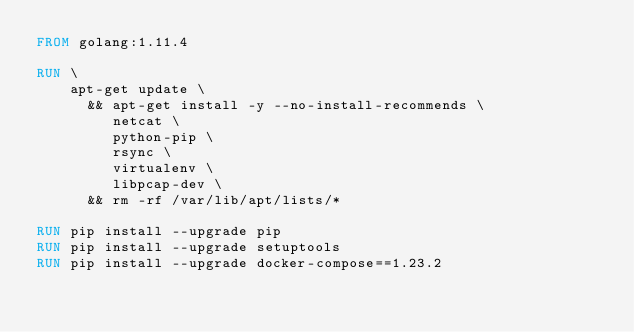Convert code to text. <code><loc_0><loc_0><loc_500><loc_500><_Dockerfile_>FROM golang:1.11.4

RUN \
    apt-get update \
      && apt-get install -y --no-install-recommends \
         netcat \
         python-pip \
         rsync \
         virtualenv \
         libpcap-dev \
      && rm -rf /var/lib/apt/lists/*

RUN pip install --upgrade pip
RUN pip install --upgrade setuptools
RUN pip install --upgrade docker-compose==1.23.2
</code> 